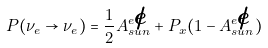<formula> <loc_0><loc_0><loc_500><loc_500>P ( \nu _ { e } \rightarrow \nu _ { e } ) = { \frac { 1 } { 2 } } A _ { s u n } ^ { e \not e } + P _ { x } ( 1 - A _ { s u n } ^ { e \not e } ) \,</formula> 